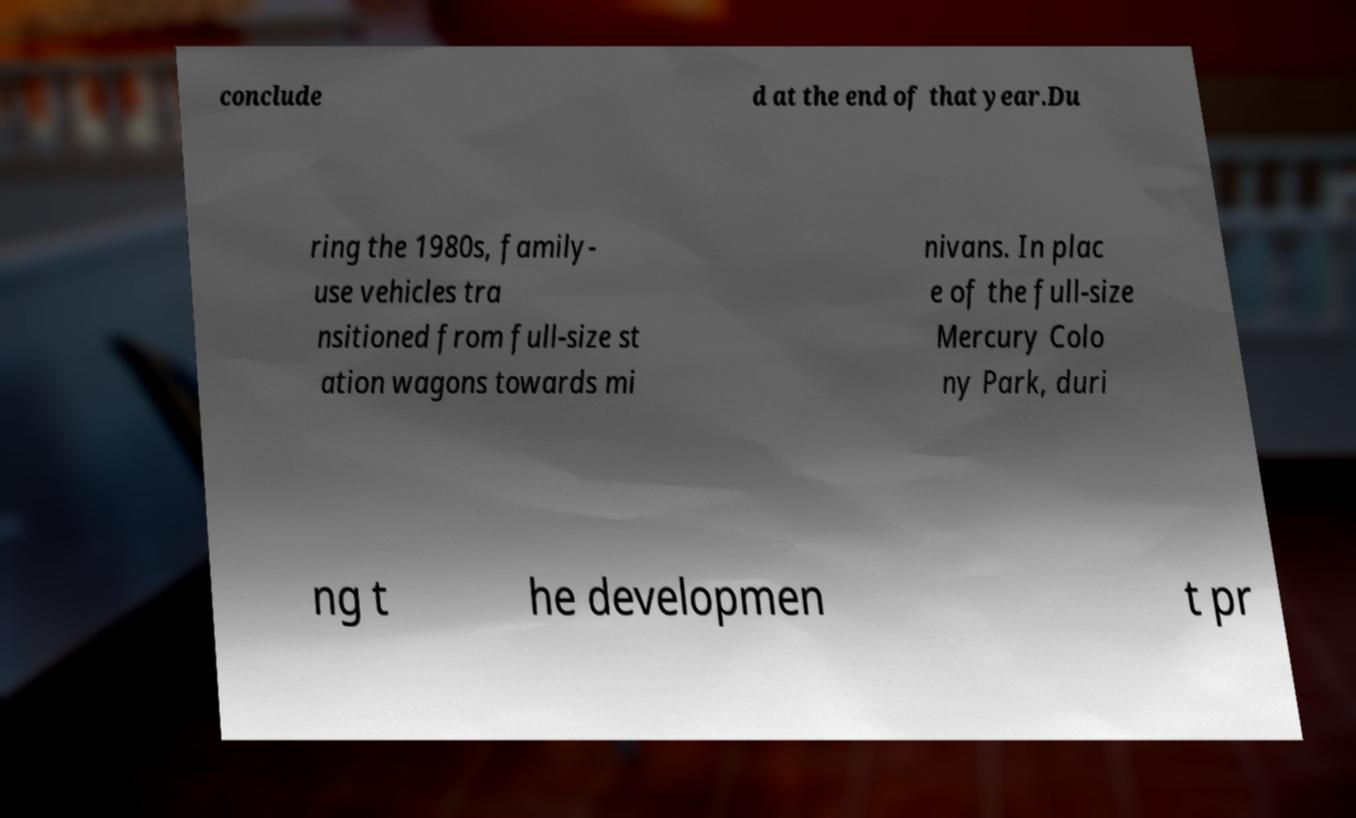Could you assist in decoding the text presented in this image and type it out clearly? conclude d at the end of that year.Du ring the 1980s, family- use vehicles tra nsitioned from full-size st ation wagons towards mi nivans. In plac e of the full-size Mercury Colo ny Park, duri ng t he developmen t pr 